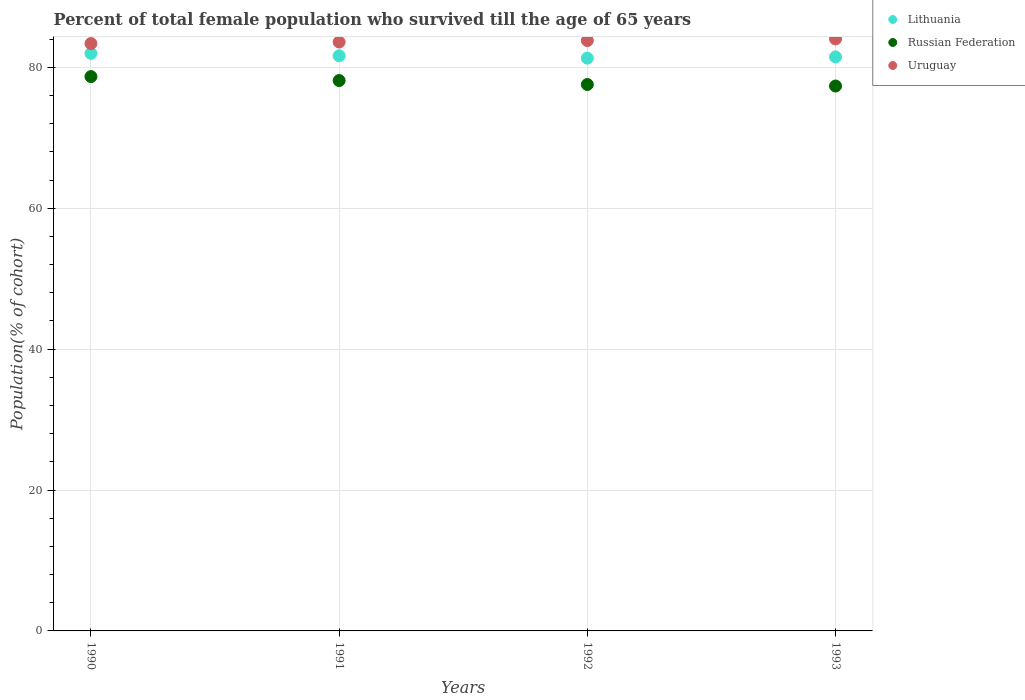What is the percentage of total female population who survived till the age of 65 years in Lithuania in 1993?
Offer a very short reply. 81.47. Across all years, what is the maximum percentage of total female population who survived till the age of 65 years in Russian Federation?
Offer a terse response. 78.68. Across all years, what is the minimum percentage of total female population who survived till the age of 65 years in Lithuania?
Ensure brevity in your answer.  81.3. What is the total percentage of total female population who survived till the age of 65 years in Russian Federation in the graph?
Provide a short and direct response. 311.69. What is the difference between the percentage of total female population who survived till the age of 65 years in Lithuania in 1990 and that in 1992?
Make the answer very short. 0.67. What is the difference between the percentage of total female population who survived till the age of 65 years in Lithuania in 1991 and the percentage of total female population who survived till the age of 65 years in Russian Federation in 1992?
Keep it short and to the point. 4.08. What is the average percentage of total female population who survived till the age of 65 years in Russian Federation per year?
Your answer should be very brief. 77.92. In the year 1992, what is the difference between the percentage of total female population who survived till the age of 65 years in Uruguay and percentage of total female population who survived till the age of 65 years in Russian Federation?
Provide a short and direct response. 6.24. What is the ratio of the percentage of total female population who survived till the age of 65 years in Russian Federation in 1990 to that in 1992?
Give a very brief answer. 1.01. Is the percentage of total female population who survived till the age of 65 years in Uruguay in 1991 less than that in 1992?
Keep it short and to the point. Yes. Is the difference between the percentage of total female population who survived till the age of 65 years in Uruguay in 1990 and 1991 greater than the difference between the percentage of total female population who survived till the age of 65 years in Russian Federation in 1990 and 1991?
Provide a succinct answer. No. What is the difference between the highest and the second highest percentage of total female population who survived till the age of 65 years in Russian Federation?
Offer a terse response. 0.56. What is the difference between the highest and the lowest percentage of total female population who survived till the age of 65 years in Russian Federation?
Keep it short and to the point. 1.34. Is it the case that in every year, the sum of the percentage of total female population who survived till the age of 65 years in Russian Federation and percentage of total female population who survived till the age of 65 years in Uruguay  is greater than the percentage of total female population who survived till the age of 65 years in Lithuania?
Give a very brief answer. Yes. Does the percentage of total female population who survived till the age of 65 years in Lithuania monotonically increase over the years?
Your response must be concise. No. Is the percentage of total female population who survived till the age of 65 years in Uruguay strictly less than the percentage of total female population who survived till the age of 65 years in Russian Federation over the years?
Offer a very short reply. No. How many years are there in the graph?
Give a very brief answer. 4. What is the difference between two consecutive major ticks on the Y-axis?
Offer a terse response. 20. Does the graph contain grids?
Offer a terse response. Yes. How are the legend labels stacked?
Offer a very short reply. Vertical. What is the title of the graph?
Ensure brevity in your answer.  Percent of total female population who survived till the age of 65 years. What is the label or title of the Y-axis?
Your response must be concise. Population(% of cohort). What is the Population(% of cohort) in Lithuania in 1990?
Give a very brief answer. 81.97. What is the Population(% of cohort) of Russian Federation in 1990?
Make the answer very short. 78.68. What is the Population(% of cohort) of Uruguay in 1990?
Provide a short and direct response. 83.37. What is the Population(% of cohort) of Lithuania in 1991?
Make the answer very short. 81.63. What is the Population(% of cohort) of Russian Federation in 1991?
Make the answer very short. 78.12. What is the Population(% of cohort) in Uruguay in 1991?
Make the answer very short. 83.58. What is the Population(% of cohort) in Lithuania in 1992?
Your answer should be very brief. 81.3. What is the Population(% of cohort) in Russian Federation in 1992?
Keep it short and to the point. 77.56. What is the Population(% of cohort) of Uruguay in 1992?
Provide a short and direct response. 83.8. What is the Population(% of cohort) in Lithuania in 1993?
Offer a very short reply. 81.47. What is the Population(% of cohort) of Russian Federation in 1993?
Offer a terse response. 77.34. What is the Population(% of cohort) in Uruguay in 1993?
Your answer should be very brief. 84.02. Across all years, what is the maximum Population(% of cohort) in Lithuania?
Offer a very short reply. 81.97. Across all years, what is the maximum Population(% of cohort) of Russian Federation?
Ensure brevity in your answer.  78.68. Across all years, what is the maximum Population(% of cohort) of Uruguay?
Provide a short and direct response. 84.02. Across all years, what is the minimum Population(% of cohort) of Lithuania?
Your answer should be very brief. 81.3. Across all years, what is the minimum Population(% of cohort) in Russian Federation?
Ensure brevity in your answer.  77.34. Across all years, what is the minimum Population(% of cohort) in Uruguay?
Keep it short and to the point. 83.37. What is the total Population(% of cohort) of Lithuania in the graph?
Your answer should be compact. 326.37. What is the total Population(% of cohort) of Russian Federation in the graph?
Keep it short and to the point. 311.69. What is the total Population(% of cohort) in Uruguay in the graph?
Your answer should be compact. 334.77. What is the difference between the Population(% of cohort) of Lithuania in 1990 and that in 1991?
Keep it short and to the point. 0.33. What is the difference between the Population(% of cohort) of Russian Federation in 1990 and that in 1991?
Your answer should be very brief. 0.56. What is the difference between the Population(% of cohort) of Uruguay in 1990 and that in 1991?
Keep it short and to the point. -0.21. What is the difference between the Population(% of cohort) of Lithuania in 1990 and that in 1992?
Your answer should be compact. 0.67. What is the difference between the Population(% of cohort) in Russian Federation in 1990 and that in 1992?
Make the answer very short. 1.12. What is the difference between the Population(% of cohort) in Uruguay in 1990 and that in 1992?
Your response must be concise. -0.42. What is the difference between the Population(% of cohort) in Lithuania in 1990 and that in 1993?
Your answer should be compact. 0.49. What is the difference between the Population(% of cohort) in Russian Federation in 1990 and that in 1993?
Offer a terse response. 1.34. What is the difference between the Population(% of cohort) of Uruguay in 1990 and that in 1993?
Provide a short and direct response. -0.65. What is the difference between the Population(% of cohort) of Lithuania in 1991 and that in 1992?
Provide a succinct answer. 0.33. What is the difference between the Population(% of cohort) of Russian Federation in 1991 and that in 1992?
Your answer should be very brief. 0.56. What is the difference between the Population(% of cohort) in Uruguay in 1991 and that in 1992?
Give a very brief answer. -0.21. What is the difference between the Population(% of cohort) in Lithuania in 1991 and that in 1993?
Offer a very short reply. 0.16. What is the difference between the Population(% of cohort) of Russian Federation in 1991 and that in 1993?
Offer a very short reply. 0.78. What is the difference between the Population(% of cohort) of Uruguay in 1991 and that in 1993?
Provide a succinct answer. -0.44. What is the difference between the Population(% of cohort) in Lithuania in 1992 and that in 1993?
Offer a very short reply. -0.18. What is the difference between the Population(% of cohort) in Russian Federation in 1992 and that in 1993?
Your answer should be compact. 0.22. What is the difference between the Population(% of cohort) in Uruguay in 1992 and that in 1993?
Your answer should be very brief. -0.23. What is the difference between the Population(% of cohort) of Lithuania in 1990 and the Population(% of cohort) of Russian Federation in 1991?
Offer a terse response. 3.85. What is the difference between the Population(% of cohort) in Lithuania in 1990 and the Population(% of cohort) in Uruguay in 1991?
Provide a succinct answer. -1.62. What is the difference between the Population(% of cohort) in Russian Federation in 1990 and the Population(% of cohort) in Uruguay in 1991?
Offer a terse response. -4.9. What is the difference between the Population(% of cohort) of Lithuania in 1990 and the Population(% of cohort) of Russian Federation in 1992?
Your answer should be compact. 4.41. What is the difference between the Population(% of cohort) of Lithuania in 1990 and the Population(% of cohort) of Uruguay in 1992?
Ensure brevity in your answer.  -1.83. What is the difference between the Population(% of cohort) in Russian Federation in 1990 and the Population(% of cohort) in Uruguay in 1992?
Make the answer very short. -5.12. What is the difference between the Population(% of cohort) of Lithuania in 1990 and the Population(% of cohort) of Russian Federation in 1993?
Your answer should be very brief. 4.63. What is the difference between the Population(% of cohort) in Lithuania in 1990 and the Population(% of cohort) in Uruguay in 1993?
Keep it short and to the point. -2.06. What is the difference between the Population(% of cohort) in Russian Federation in 1990 and the Population(% of cohort) in Uruguay in 1993?
Offer a very short reply. -5.34. What is the difference between the Population(% of cohort) in Lithuania in 1991 and the Population(% of cohort) in Russian Federation in 1992?
Keep it short and to the point. 4.08. What is the difference between the Population(% of cohort) in Lithuania in 1991 and the Population(% of cohort) in Uruguay in 1992?
Keep it short and to the point. -2.16. What is the difference between the Population(% of cohort) in Russian Federation in 1991 and the Population(% of cohort) in Uruguay in 1992?
Give a very brief answer. -5.68. What is the difference between the Population(% of cohort) in Lithuania in 1991 and the Population(% of cohort) in Russian Federation in 1993?
Provide a short and direct response. 4.29. What is the difference between the Population(% of cohort) of Lithuania in 1991 and the Population(% of cohort) of Uruguay in 1993?
Provide a short and direct response. -2.39. What is the difference between the Population(% of cohort) in Russian Federation in 1991 and the Population(% of cohort) in Uruguay in 1993?
Make the answer very short. -5.91. What is the difference between the Population(% of cohort) of Lithuania in 1992 and the Population(% of cohort) of Russian Federation in 1993?
Your answer should be very brief. 3.96. What is the difference between the Population(% of cohort) of Lithuania in 1992 and the Population(% of cohort) of Uruguay in 1993?
Provide a succinct answer. -2.73. What is the difference between the Population(% of cohort) in Russian Federation in 1992 and the Population(% of cohort) in Uruguay in 1993?
Provide a succinct answer. -6.47. What is the average Population(% of cohort) in Lithuania per year?
Your answer should be very brief. 81.59. What is the average Population(% of cohort) in Russian Federation per year?
Make the answer very short. 77.92. What is the average Population(% of cohort) of Uruguay per year?
Your response must be concise. 83.69. In the year 1990, what is the difference between the Population(% of cohort) in Lithuania and Population(% of cohort) in Russian Federation?
Your answer should be very brief. 3.29. In the year 1990, what is the difference between the Population(% of cohort) of Lithuania and Population(% of cohort) of Uruguay?
Provide a short and direct response. -1.41. In the year 1990, what is the difference between the Population(% of cohort) in Russian Federation and Population(% of cohort) in Uruguay?
Provide a short and direct response. -4.69. In the year 1991, what is the difference between the Population(% of cohort) in Lithuania and Population(% of cohort) in Russian Federation?
Offer a terse response. 3.51. In the year 1991, what is the difference between the Population(% of cohort) in Lithuania and Population(% of cohort) in Uruguay?
Your answer should be very brief. -1.95. In the year 1991, what is the difference between the Population(% of cohort) of Russian Federation and Population(% of cohort) of Uruguay?
Keep it short and to the point. -5.47. In the year 1992, what is the difference between the Population(% of cohort) in Lithuania and Population(% of cohort) in Russian Federation?
Offer a very short reply. 3.74. In the year 1992, what is the difference between the Population(% of cohort) of Lithuania and Population(% of cohort) of Uruguay?
Give a very brief answer. -2.5. In the year 1992, what is the difference between the Population(% of cohort) in Russian Federation and Population(% of cohort) in Uruguay?
Your answer should be compact. -6.24. In the year 1993, what is the difference between the Population(% of cohort) of Lithuania and Population(% of cohort) of Russian Federation?
Make the answer very short. 4.13. In the year 1993, what is the difference between the Population(% of cohort) of Lithuania and Population(% of cohort) of Uruguay?
Your response must be concise. -2.55. In the year 1993, what is the difference between the Population(% of cohort) in Russian Federation and Population(% of cohort) in Uruguay?
Your response must be concise. -6.68. What is the ratio of the Population(% of cohort) of Uruguay in 1990 to that in 1991?
Your answer should be very brief. 1. What is the ratio of the Population(% of cohort) of Lithuania in 1990 to that in 1992?
Provide a succinct answer. 1.01. What is the ratio of the Population(% of cohort) of Russian Federation in 1990 to that in 1992?
Your response must be concise. 1.01. What is the ratio of the Population(% of cohort) of Uruguay in 1990 to that in 1992?
Provide a succinct answer. 0.99. What is the ratio of the Population(% of cohort) in Russian Federation in 1990 to that in 1993?
Keep it short and to the point. 1.02. What is the ratio of the Population(% of cohort) in Uruguay in 1990 to that in 1993?
Ensure brevity in your answer.  0.99. What is the ratio of the Population(% of cohort) of Lithuania in 1991 to that in 1992?
Give a very brief answer. 1. What is the ratio of the Population(% of cohort) in Russian Federation in 1991 to that in 1992?
Your answer should be very brief. 1.01. What is the ratio of the Population(% of cohort) of Uruguay in 1991 to that in 1993?
Give a very brief answer. 0.99. What is the ratio of the Population(% of cohort) in Uruguay in 1992 to that in 1993?
Provide a succinct answer. 1. What is the difference between the highest and the second highest Population(% of cohort) of Lithuania?
Offer a very short reply. 0.33. What is the difference between the highest and the second highest Population(% of cohort) in Russian Federation?
Your answer should be very brief. 0.56. What is the difference between the highest and the second highest Population(% of cohort) in Uruguay?
Your answer should be compact. 0.23. What is the difference between the highest and the lowest Population(% of cohort) of Lithuania?
Your answer should be very brief. 0.67. What is the difference between the highest and the lowest Population(% of cohort) of Russian Federation?
Your answer should be very brief. 1.34. What is the difference between the highest and the lowest Population(% of cohort) of Uruguay?
Provide a short and direct response. 0.65. 